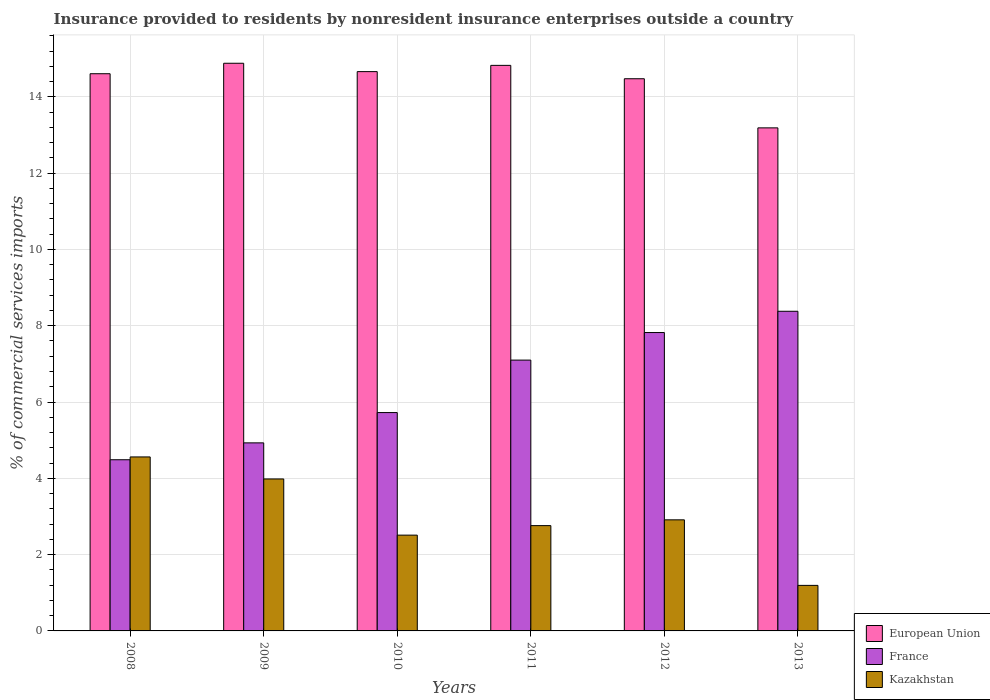How many different coloured bars are there?
Your answer should be very brief. 3. How many groups of bars are there?
Keep it short and to the point. 6. Are the number of bars per tick equal to the number of legend labels?
Keep it short and to the point. Yes. Are the number of bars on each tick of the X-axis equal?
Your answer should be very brief. Yes. How many bars are there on the 4th tick from the right?
Offer a very short reply. 3. What is the Insurance provided to residents in France in 2010?
Give a very brief answer. 5.72. Across all years, what is the maximum Insurance provided to residents in European Union?
Ensure brevity in your answer.  14.88. Across all years, what is the minimum Insurance provided to residents in European Union?
Keep it short and to the point. 13.19. What is the total Insurance provided to residents in Kazakhstan in the graph?
Offer a terse response. 17.92. What is the difference between the Insurance provided to residents in Kazakhstan in 2008 and that in 2010?
Your answer should be very brief. 2.05. What is the difference between the Insurance provided to residents in European Union in 2009 and the Insurance provided to residents in Kazakhstan in 2013?
Give a very brief answer. 13.69. What is the average Insurance provided to residents in France per year?
Your answer should be compact. 6.41. In the year 2013, what is the difference between the Insurance provided to residents in European Union and Insurance provided to residents in Kazakhstan?
Make the answer very short. 11.99. What is the ratio of the Insurance provided to residents in European Union in 2008 to that in 2009?
Provide a succinct answer. 0.98. What is the difference between the highest and the second highest Insurance provided to residents in European Union?
Ensure brevity in your answer.  0.06. What is the difference between the highest and the lowest Insurance provided to residents in France?
Your answer should be very brief. 3.89. Is the sum of the Insurance provided to residents in European Union in 2009 and 2013 greater than the maximum Insurance provided to residents in France across all years?
Provide a succinct answer. Yes. What does the 2nd bar from the left in 2008 represents?
Ensure brevity in your answer.  France. What does the 1st bar from the right in 2013 represents?
Your answer should be compact. Kazakhstan. Are all the bars in the graph horizontal?
Provide a short and direct response. No. How many years are there in the graph?
Give a very brief answer. 6. Are the values on the major ticks of Y-axis written in scientific E-notation?
Keep it short and to the point. No. Does the graph contain grids?
Give a very brief answer. Yes. Where does the legend appear in the graph?
Keep it short and to the point. Bottom right. How are the legend labels stacked?
Provide a short and direct response. Vertical. What is the title of the graph?
Keep it short and to the point. Insurance provided to residents by nonresident insurance enterprises outside a country. What is the label or title of the Y-axis?
Keep it short and to the point. % of commercial services imports. What is the % of commercial services imports in European Union in 2008?
Your answer should be compact. 14.6. What is the % of commercial services imports of France in 2008?
Give a very brief answer. 4.49. What is the % of commercial services imports of Kazakhstan in 2008?
Provide a short and direct response. 4.56. What is the % of commercial services imports of European Union in 2009?
Offer a terse response. 14.88. What is the % of commercial services imports in France in 2009?
Make the answer very short. 4.93. What is the % of commercial services imports in Kazakhstan in 2009?
Provide a succinct answer. 3.98. What is the % of commercial services imports of European Union in 2010?
Offer a terse response. 14.66. What is the % of commercial services imports of France in 2010?
Your response must be concise. 5.72. What is the % of commercial services imports of Kazakhstan in 2010?
Your response must be concise. 2.51. What is the % of commercial services imports of European Union in 2011?
Keep it short and to the point. 14.82. What is the % of commercial services imports in France in 2011?
Offer a terse response. 7.1. What is the % of commercial services imports in Kazakhstan in 2011?
Ensure brevity in your answer.  2.76. What is the % of commercial services imports of European Union in 2012?
Make the answer very short. 14.47. What is the % of commercial services imports in France in 2012?
Keep it short and to the point. 7.82. What is the % of commercial services imports in Kazakhstan in 2012?
Offer a very short reply. 2.91. What is the % of commercial services imports of European Union in 2013?
Offer a terse response. 13.19. What is the % of commercial services imports in France in 2013?
Ensure brevity in your answer.  8.38. What is the % of commercial services imports of Kazakhstan in 2013?
Provide a succinct answer. 1.19. Across all years, what is the maximum % of commercial services imports in European Union?
Offer a very short reply. 14.88. Across all years, what is the maximum % of commercial services imports of France?
Make the answer very short. 8.38. Across all years, what is the maximum % of commercial services imports of Kazakhstan?
Make the answer very short. 4.56. Across all years, what is the minimum % of commercial services imports of European Union?
Keep it short and to the point. 13.19. Across all years, what is the minimum % of commercial services imports in France?
Provide a short and direct response. 4.49. Across all years, what is the minimum % of commercial services imports of Kazakhstan?
Keep it short and to the point. 1.19. What is the total % of commercial services imports of European Union in the graph?
Your answer should be compact. 86.63. What is the total % of commercial services imports of France in the graph?
Provide a short and direct response. 38.44. What is the total % of commercial services imports in Kazakhstan in the graph?
Keep it short and to the point. 17.92. What is the difference between the % of commercial services imports in European Union in 2008 and that in 2009?
Keep it short and to the point. -0.27. What is the difference between the % of commercial services imports of France in 2008 and that in 2009?
Your answer should be very brief. -0.44. What is the difference between the % of commercial services imports of Kazakhstan in 2008 and that in 2009?
Your answer should be very brief. 0.58. What is the difference between the % of commercial services imports of European Union in 2008 and that in 2010?
Provide a short and direct response. -0.06. What is the difference between the % of commercial services imports in France in 2008 and that in 2010?
Provide a short and direct response. -1.24. What is the difference between the % of commercial services imports in Kazakhstan in 2008 and that in 2010?
Your answer should be compact. 2.05. What is the difference between the % of commercial services imports in European Union in 2008 and that in 2011?
Provide a succinct answer. -0.22. What is the difference between the % of commercial services imports in France in 2008 and that in 2011?
Provide a succinct answer. -2.61. What is the difference between the % of commercial services imports of Kazakhstan in 2008 and that in 2011?
Your response must be concise. 1.8. What is the difference between the % of commercial services imports of European Union in 2008 and that in 2012?
Keep it short and to the point. 0.13. What is the difference between the % of commercial services imports of France in 2008 and that in 2012?
Provide a succinct answer. -3.33. What is the difference between the % of commercial services imports in Kazakhstan in 2008 and that in 2012?
Offer a very short reply. 1.65. What is the difference between the % of commercial services imports in European Union in 2008 and that in 2013?
Your response must be concise. 1.42. What is the difference between the % of commercial services imports of France in 2008 and that in 2013?
Give a very brief answer. -3.89. What is the difference between the % of commercial services imports in Kazakhstan in 2008 and that in 2013?
Offer a terse response. 3.37. What is the difference between the % of commercial services imports of European Union in 2009 and that in 2010?
Your answer should be very brief. 0.22. What is the difference between the % of commercial services imports of France in 2009 and that in 2010?
Provide a short and direct response. -0.79. What is the difference between the % of commercial services imports in Kazakhstan in 2009 and that in 2010?
Provide a short and direct response. 1.47. What is the difference between the % of commercial services imports in European Union in 2009 and that in 2011?
Your answer should be compact. 0.06. What is the difference between the % of commercial services imports in France in 2009 and that in 2011?
Provide a short and direct response. -2.17. What is the difference between the % of commercial services imports in Kazakhstan in 2009 and that in 2011?
Offer a very short reply. 1.22. What is the difference between the % of commercial services imports of European Union in 2009 and that in 2012?
Your response must be concise. 0.41. What is the difference between the % of commercial services imports of France in 2009 and that in 2012?
Provide a succinct answer. -2.89. What is the difference between the % of commercial services imports in Kazakhstan in 2009 and that in 2012?
Your response must be concise. 1.07. What is the difference between the % of commercial services imports in European Union in 2009 and that in 2013?
Provide a succinct answer. 1.69. What is the difference between the % of commercial services imports of France in 2009 and that in 2013?
Keep it short and to the point. -3.45. What is the difference between the % of commercial services imports of Kazakhstan in 2009 and that in 2013?
Ensure brevity in your answer.  2.79. What is the difference between the % of commercial services imports in European Union in 2010 and that in 2011?
Make the answer very short. -0.16. What is the difference between the % of commercial services imports of France in 2010 and that in 2011?
Your answer should be compact. -1.38. What is the difference between the % of commercial services imports in Kazakhstan in 2010 and that in 2011?
Offer a very short reply. -0.25. What is the difference between the % of commercial services imports of European Union in 2010 and that in 2012?
Ensure brevity in your answer.  0.19. What is the difference between the % of commercial services imports of France in 2010 and that in 2012?
Ensure brevity in your answer.  -2.1. What is the difference between the % of commercial services imports in Kazakhstan in 2010 and that in 2012?
Provide a short and direct response. -0.4. What is the difference between the % of commercial services imports in European Union in 2010 and that in 2013?
Offer a terse response. 1.47. What is the difference between the % of commercial services imports in France in 2010 and that in 2013?
Keep it short and to the point. -2.66. What is the difference between the % of commercial services imports in Kazakhstan in 2010 and that in 2013?
Provide a short and direct response. 1.32. What is the difference between the % of commercial services imports in European Union in 2011 and that in 2012?
Keep it short and to the point. 0.35. What is the difference between the % of commercial services imports in France in 2011 and that in 2012?
Give a very brief answer. -0.72. What is the difference between the % of commercial services imports of Kazakhstan in 2011 and that in 2012?
Your response must be concise. -0.15. What is the difference between the % of commercial services imports in European Union in 2011 and that in 2013?
Give a very brief answer. 1.64. What is the difference between the % of commercial services imports in France in 2011 and that in 2013?
Your response must be concise. -1.28. What is the difference between the % of commercial services imports in Kazakhstan in 2011 and that in 2013?
Your answer should be compact. 1.57. What is the difference between the % of commercial services imports of European Union in 2012 and that in 2013?
Provide a succinct answer. 1.29. What is the difference between the % of commercial services imports in France in 2012 and that in 2013?
Provide a succinct answer. -0.56. What is the difference between the % of commercial services imports in Kazakhstan in 2012 and that in 2013?
Give a very brief answer. 1.72. What is the difference between the % of commercial services imports of European Union in 2008 and the % of commercial services imports of France in 2009?
Your response must be concise. 9.68. What is the difference between the % of commercial services imports of European Union in 2008 and the % of commercial services imports of Kazakhstan in 2009?
Your answer should be very brief. 10.62. What is the difference between the % of commercial services imports in France in 2008 and the % of commercial services imports in Kazakhstan in 2009?
Make the answer very short. 0.5. What is the difference between the % of commercial services imports of European Union in 2008 and the % of commercial services imports of France in 2010?
Offer a very short reply. 8.88. What is the difference between the % of commercial services imports of European Union in 2008 and the % of commercial services imports of Kazakhstan in 2010?
Provide a succinct answer. 12.09. What is the difference between the % of commercial services imports in France in 2008 and the % of commercial services imports in Kazakhstan in 2010?
Ensure brevity in your answer.  1.98. What is the difference between the % of commercial services imports in European Union in 2008 and the % of commercial services imports in France in 2011?
Your answer should be compact. 7.51. What is the difference between the % of commercial services imports of European Union in 2008 and the % of commercial services imports of Kazakhstan in 2011?
Your answer should be very brief. 11.84. What is the difference between the % of commercial services imports in France in 2008 and the % of commercial services imports in Kazakhstan in 2011?
Provide a succinct answer. 1.73. What is the difference between the % of commercial services imports of European Union in 2008 and the % of commercial services imports of France in 2012?
Give a very brief answer. 6.78. What is the difference between the % of commercial services imports of European Union in 2008 and the % of commercial services imports of Kazakhstan in 2012?
Make the answer very short. 11.69. What is the difference between the % of commercial services imports in France in 2008 and the % of commercial services imports in Kazakhstan in 2012?
Make the answer very short. 1.58. What is the difference between the % of commercial services imports in European Union in 2008 and the % of commercial services imports in France in 2013?
Provide a short and direct response. 6.23. What is the difference between the % of commercial services imports of European Union in 2008 and the % of commercial services imports of Kazakhstan in 2013?
Offer a very short reply. 13.41. What is the difference between the % of commercial services imports in France in 2008 and the % of commercial services imports in Kazakhstan in 2013?
Offer a very short reply. 3.29. What is the difference between the % of commercial services imports of European Union in 2009 and the % of commercial services imports of France in 2010?
Keep it short and to the point. 9.16. What is the difference between the % of commercial services imports of European Union in 2009 and the % of commercial services imports of Kazakhstan in 2010?
Ensure brevity in your answer.  12.37. What is the difference between the % of commercial services imports in France in 2009 and the % of commercial services imports in Kazakhstan in 2010?
Keep it short and to the point. 2.42. What is the difference between the % of commercial services imports of European Union in 2009 and the % of commercial services imports of France in 2011?
Your answer should be compact. 7.78. What is the difference between the % of commercial services imports of European Union in 2009 and the % of commercial services imports of Kazakhstan in 2011?
Make the answer very short. 12.12. What is the difference between the % of commercial services imports in France in 2009 and the % of commercial services imports in Kazakhstan in 2011?
Your answer should be compact. 2.17. What is the difference between the % of commercial services imports in European Union in 2009 and the % of commercial services imports in France in 2012?
Offer a terse response. 7.06. What is the difference between the % of commercial services imports in European Union in 2009 and the % of commercial services imports in Kazakhstan in 2012?
Give a very brief answer. 11.97. What is the difference between the % of commercial services imports of France in 2009 and the % of commercial services imports of Kazakhstan in 2012?
Keep it short and to the point. 2.02. What is the difference between the % of commercial services imports in European Union in 2009 and the % of commercial services imports in France in 2013?
Your answer should be very brief. 6.5. What is the difference between the % of commercial services imports of European Union in 2009 and the % of commercial services imports of Kazakhstan in 2013?
Make the answer very short. 13.69. What is the difference between the % of commercial services imports in France in 2009 and the % of commercial services imports in Kazakhstan in 2013?
Keep it short and to the point. 3.74. What is the difference between the % of commercial services imports in European Union in 2010 and the % of commercial services imports in France in 2011?
Your response must be concise. 7.56. What is the difference between the % of commercial services imports in France in 2010 and the % of commercial services imports in Kazakhstan in 2011?
Your answer should be very brief. 2.96. What is the difference between the % of commercial services imports of European Union in 2010 and the % of commercial services imports of France in 2012?
Your answer should be very brief. 6.84. What is the difference between the % of commercial services imports of European Union in 2010 and the % of commercial services imports of Kazakhstan in 2012?
Make the answer very short. 11.75. What is the difference between the % of commercial services imports in France in 2010 and the % of commercial services imports in Kazakhstan in 2012?
Make the answer very short. 2.81. What is the difference between the % of commercial services imports in European Union in 2010 and the % of commercial services imports in France in 2013?
Your response must be concise. 6.28. What is the difference between the % of commercial services imports in European Union in 2010 and the % of commercial services imports in Kazakhstan in 2013?
Give a very brief answer. 13.47. What is the difference between the % of commercial services imports of France in 2010 and the % of commercial services imports of Kazakhstan in 2013?
Provide a succinct answer. 4.53. What is the difference between the % of commercial services imports of European Union in 2011 and the % of commercial services imports of France in 2012?
Your response must be concise. 7. What is the difference between the % of commercial services imports of European Union in 2011 and the % of commercial services imports of Kazakhstan in 2012?
Make the answer very short. 11.91. What is the difference between the % of commercial services imports in France in 2011 and the % of commercial services imports in Kazakhstan in 2012?
Your answer should be compact. 4.19. What is the difference between the % of commercial services imports of European Union in 2011 and the % of commercial services imports of France in 2013?
Offer a terse response. 6.45. What is the difference between the % of commercial services imports in European Union in 2011 and the % of commercial services imports in Kazakhstan in 2013?
Make the answer very short. 13.63. What is the difference between the % of commercial services imports of France in 2011 and the % of commercial services imports of Kazakhstan in 2013?
Your response must be concise. 5.9. What is the difference between the % of commercial services imports of European Union in 2012 and the % of commercial services imports of France in 2013?
Give a very brief answer. 6.09. What is the difference between the % of commercial services imports of European Union in 2012 and the % of commercial services imports of Kazakhstan in 2013?
Keep it short and to the point. 13.28. What is the difference between the % of commercial services imports of France in 2012 and the % of commercial services imports of Kazakhstan in 2013?
Ensure brevity in your answer.  6.63. What is the average % of commercial services imports in European Union per year?
Provide a succinct answer. 14.44. What is the average % of commercial services imports in France per year?
Offer a very short reply. 6.41. What is the average % of commercial services imports in Kazakhstan per year?
Provide a short and direct response. 2.99. In the year 2008, what is the difference between the % of commercial services imports in European Union and % of commercial services imports in France?
Your response must be concise. 10.12. In the year 2008, what is the difference between the % of commercial services imports of European Union and % of commercial services imports of Kazakhstan?
Ensure brevity in your answer.  10.04. In the year 2008, what is the difference between the % of commercial services imports of France and % of commercial services imports of Kazakhstan?
Offer a terse response. -0.07. In the year 2009, what is the difference between the % of commercial services imports in European Union and % of commercial services imports in France?
Your answer should be very brief. 9.95. In the year 2009, what is the difference between the % of commercial services imports of European Union and % of commercial services imports of Kazakhstan?
Your response must be concise. 10.9. In the year 2009, what is the difference between the % of commercial services imports in France and % of commercial services imports in Kazakhstan?
Provide a short and direct response. 0.95. In the year 2010, what is the difference between the % of commercial services imports in European Union and % of commercial services imports in France?
Ensure brevity in your answer.  8.94. In the year 2010, what is the difference between the % of commercial services imports in European Union and % of commercial services imports in Kazakhstan?
Keep it short and to the point. 12.15. In the year 2010, what is the difference between the % of commercial services imports of France and % of commercial services imports of Kazakhstan?
Offer a very short reply. 3.21. In the year 2011, what is the difference between the % of commercial services imports of European Union and % of commercial services imports of France?
Offer a terse response. 7.73. In the year 2011, what is the difference between the % of commercial services imports in European Union and % of commercial services imports in Kazakhstan?
Offer a terse response. 12.06. In the year 2011, what is the difference between the % of commercial services imports of France and % of commercial services imports of Kazakhstan?
Give a very brief answer. 4.34. In the year 2012, what is the difference between the % of commercial services imports of European Union and % of commercial services imports of France?
Give a very brief answer. 6.65. In the year 2012, what is the difference between the % of commercial services imports of European Union and % of commercial services imports of Kazakhstan?
Make the answer very short. 11.56. In the year 2012, what is the difference between the % of commercial services imports of France and % of commercial services imports of Kazakhstan?
Make the answer very short. 4.91. In the year 2013, what is the difference between the % of commercial services imports of European Union and % of commercial services imports of France?
Your response must be concise. 4.81. In the year 2013, what is the difference between the % of commercial services imports of European Union and % of commercial services imports of Kazakhstan?
Your response must be concise. 11.99. In the year 2013, what is the difference between the % of commercial services imports in France and % of commercial services imports in Kazakhstan?
Make the answer very short. 7.18. What is the ratio of the % of commercial services imports in European Union in 2008 to that in 2009?
Provide a succinct answer. 0.98. What is the ratio of the % of commercial services imports in France in 2008 to that in 2009?
Ensure brevity in your answer.  0.91. What is the ratio of the % of commercial services imports in Kazakhstan in 2008 to that in 2009?
Offer a very short reply. 1.14. What is the ratio of the % of commercial services imports in France in 2008 to that in 2010?
Your answer should be very brief. 0.78. What is the ratio of the % of commercial services imports in Kazakhstan in 2008 to that in 2010?
Give a very brief answer. 1.82. What is the ratio of the % of commercial services imports of European Union in 2008 to that in 2011?
Your answer should be very brief. 0.99. What is the ratio of the % of commercial services imports in France in 2008 to that in 2011?
Your answer should be compact. 0.63. What is the ratio of the % of commercial services imports in Kazakhstan in 2008 to that in 2011?
Ensure brevity in your answer.  1.65. What is the ratio of the % of commercial services imports of European Union in 2008 to that in 2012?
Your response must be concise. 1.01. What is the ratio of the % of commercial services imports of France in 2008 to that in 2012?
Provide a short and direct response. 0.57. What is the ratio of the % of commercial services imports in Kazakhstan in 2008 to that in 2012?
Provide a short and direct response. 1.57. What is the ratio of the % of commercial services imports of European Union in 2008 to that in 2013?
Provide a succinct answer. 1.11. What is the ratio of the % of commercial services imports in France in 2008 to that in 2013?
Make the answer very short. 0.54. What is the ratio of the % of commercial services imports of Kazakhstan in 2008 to that in 2013?
Keep it short and to the point. 3.82. What is the ratio of the % of commercial services imports in European Union in 2009 to that in 2010?
Keep it short and to the point. 1.01. What is the ratio of the % of commercial services imports of France in 2009 to that in 2010?
Your answer should be compact. 0.86. What is the ratio of the % of commercial services imports in Kazakhstan in 2009 to that in 2010?
Your answer should be compact. 1.59. What is the ratio of the % of commercial services imports of France in 2009 to that in 2011?
Ensure brevity in your answer.  0.69. What is the ratio of the % of commercial services imports in Kazakhstan in 2009 to that in 2011?
Provide a succinct answer. 1.44. What is the ratio of the % of commercial services imports in European Union in 2009 to that in 2012?
Make the answer very short. 1.03. What is the ratio of the % of commercial services imports of France in 2009 to that in 2012?
Provide a succinct answer. 0.63. What is the ratio of the % of commercial services imports of Kazakhstan in 2009 to that in 2012?
Provide a succinct answer. 1.37. What is the ratio of the % of commercial services imports of European Union in 2009 to that in 2013?
Make the answer very short. 1.13. What is the ratio of the % of commercial services imports of France in 2009 to that in 2013?
Offer a very short reply. 0.59. What is the ratio of the % of commercial services imports in Kazakhstan in 2009 to that in 2013?
Make the answer very short. 3.34. What is the ratio of the % of commercial services imports in France in 2010 to that in 2011?
Your response must be concise. 0.81. What is the ratio of the % of commercial services imports in Kazakhstan in 2010 to that in 2011?
Offer a very short reply. 0.91. What is the ratio of the % of commercial services imports of European Union in 2010 to that in 2012?
Offer a terse response. 1.01. What is the ratio of the % of commercial services imports of France in 2010 to that in 2012?
Your response must be concise. 0.73. What is the ratio of the % of commercial services imports of Kazakhstan in 2010 to that in 2012?
Provide a succinct answer. 0.86. What is the ratio of the % of commercial services imports of European Union in 2010 to that in 2013?
Your answer should be compact. 1.11. What is the ratio of the % of commercial services imports in France in 2010 to that in 2013?
Keep it short and to the point. 0.68. What is the ratio of the % of commercial services imports of Kazakhstan in 2010 to that in 2013?
Give a very brief answer. 2.1. What is the ratio of the % of commercial services imports of European Union in 2011 to that in 2012?
Your answer should be compact. 1.02. What is the ratio of the % of commercial services imports in France in 2011 to that in 2012?
Provide a succinct answer. 0.91. What is the ratio of the % of commercial services imports in Kazakhstan in 2011 to that in 2012?
Make the answer very short. 0.95. What is the ratio of the % of commercial services imports in European Union in 2011 to that in 2013?
Ensure brevity in your answer.  1.12. What is the ratio of the % of commercial services imports in France in 2011 to that in 2013?
Your answer should be very brief. 0.85. What is the ratio of the % of commercial services imports in Kazakhstan in 2011 to that in 2013?
Make the answer very short. 2.31. What is the ratio of the % of commercial services imports of European Union in 2012 to that in 2013?
Give a very brief answer. 1.1. What is the ratio of the % of commercial services imports of France in 2012 to that in 2013?
Provide a short and direct response. 0.93. What is the ratio of the % of commercial services imports in Kazakhstan in 2012 to that in 2013?
Offer a very short reply. 2.44. What is the difference between the highest and the second highest % of commercial services imports of European Union?
Provide a short and direct response. 0.06. What is the difference between the highest and the second highest % of commercial services imports of France?
Make the answer very short. 0.56. What is the difference between the highest and the second highest % of commercial services imports of Kazakhstan?
Offer a terse response. 0.58. What is the difference between the highest and the lowest % of commercial services imports in European Union?
Ensure brevity in your answer.  1.69. What is the difference between the highest and the lowest % of commercial services imports in France?
Offer a terse response. 3.89. What is the difference between the highest and the lowest % of commercial services imports of Kazakhstan?
Offer a terse response. 3.37. 